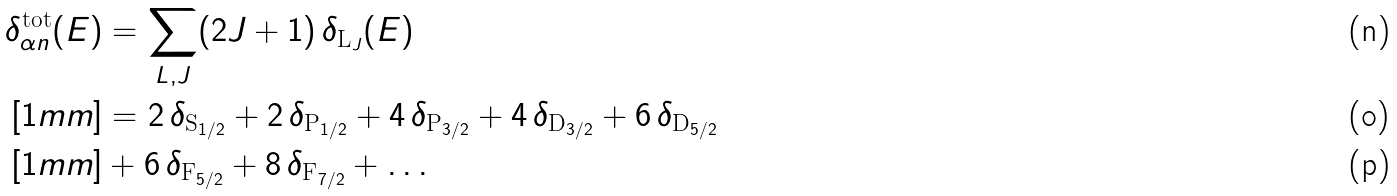Convert formula to latex. <formula><loc_0><loc_0><loc_500><loc_500>\delta ^ { \text {tot} } _ { \alpha n } ( E ) & = \sum _ { L , J } ( 2 J + 1 ) \, \delta _ { \text {L} _ { J } } ( E ) \\ [ 1 m m ] & = 2 \, \delta _ { \text {S} _ { 1 / 2 } } + 2 \, \delta _ { \text {P} _ { 1 / 2 } } + 4 \, \delta _ { \text {P} _ { 3 / 2 } } + 4 \, \delta _ { \text {D} _ { 3 / 2 } } + 6 \, \delta _ { \text {D} _ { 5 / 2 } } \\ [ 1 m m ] & + 6 \, \delta _ { \text {F} _ { 5 / 2 } } + 8 \, \delta _ { \text {F} _ { 7 / 2 } } + \dots</formula> 